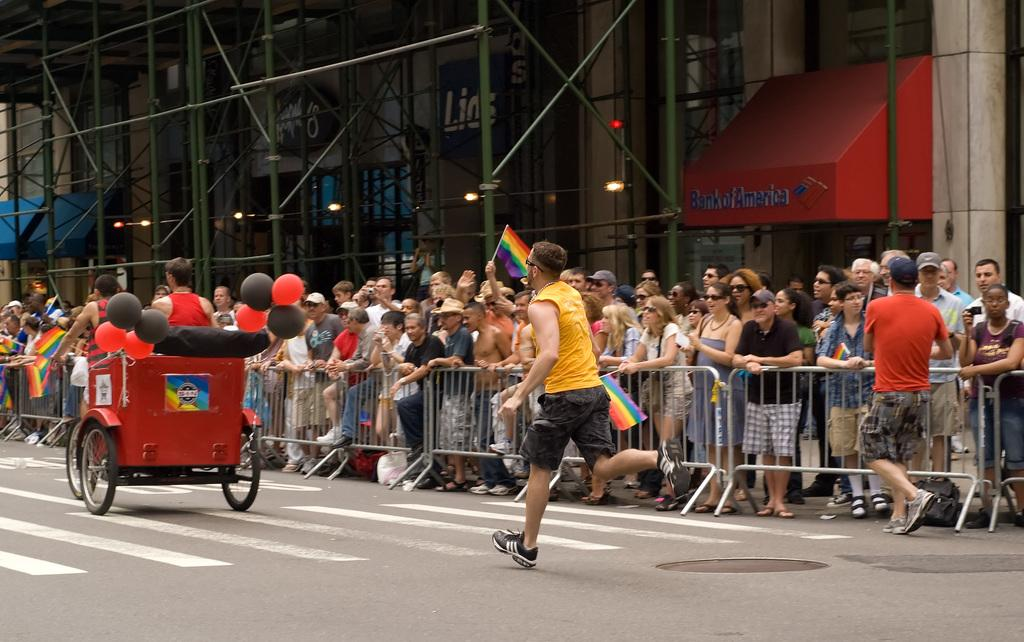What are the people in the image doing? The people in the image are standing. What is the man in the image doing? The man in the image is running on the road. What mode of transportation can be seen in the image? There is a cycle rickshaw in the image. What type of structure is visible in the image? There is a building in the image. What committee is responsible for organizing the event in the image? There is no event or committee present in the image. What process is being followed by the people in the image? The image does not provide information about any specific process being followed by the people. 